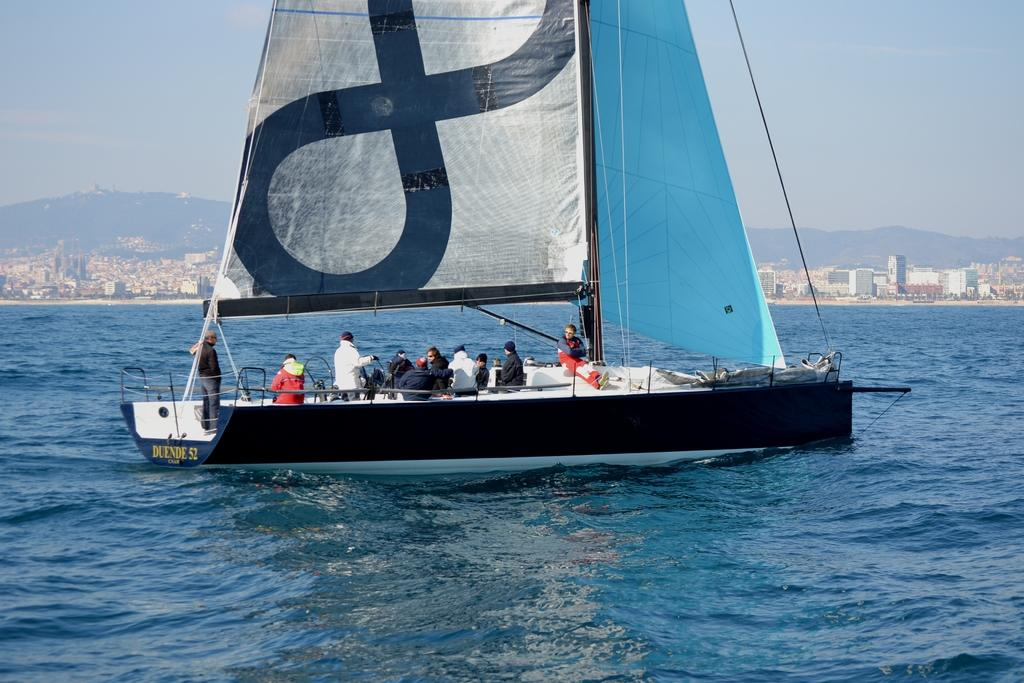What is the main subject of the image? The main subject of the image is a boat. Are there any people in the boat? Yes, there are people in the boat. What can be seen at the bottom of the image? There is water visible at the bottom of the image. What is visible in the background of the image? Mountains, buildings, and the sky are visible in the background of the image. How many ants can be seen crawling on the boat in the image? There are no ants visible in the image; it features a boat with people on it. What type of competition is taking place in the image? There is no competition present in the image; it simply shows a boat with people on it and the surrounding environment. 